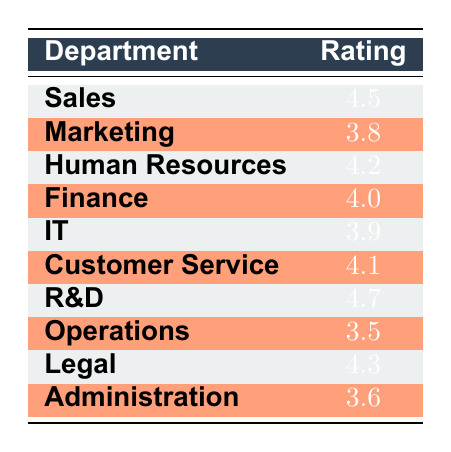What is the rating for the Human Resources department? The table displays the rating for the Human Resources department in its respective row, which is 4.2.
Answer: 4.2 Which department has the highest rating? By looking through the Ratings in the table, R&D has the highest rating at 4.7, making it the department with the best performance rating.
Answer: R&D What is the average rating of the Sales, Marketing, and IT departments? The ratings for those departments are 4.5 (Sales), 3.8 (Marketing), and 3.9 (IT). To find the average, sum them: 4.5 + 3.8 + 3.9 = 12.2, then divide by 3 (12.2 / 3 = 4.067).
Answer: 4.067 Is the rating for Customer Service higher than that of Administration? The Customer Service department has a rating of 4.1 while Administration has a rating of 3.6. Since 4.1 is greater than 3.6, the answer is yes.
Answer: Yes What is the difference in ratings between Operations and Legal departments? Operations has a rating of 3.5 and Legal has a rating of 4.3. To find the difference, subtract the rating of Operations from Legal: 4.3 - 3.5 = 0.8.
Answer: 0.8 Which departments have ratings above 4.0? The departments with ratings greater than 4.0 include Sales (4.5), Human Resources (4.2), Finance (4.0), R&D (4.7), and Legal (4.3). Therefore, there are five departments.
Answer: Five What is the median rating of all departments listed? The ratings are 4.5, 3.8, 4.2, 4.0, 3.9, 4.1, 4.7, 3.5, 4.3, and 3.6. Sorting them gives: [3.5, 3.6, 3.8, 3.9, 4.0, 4.1, 4.2, 4.3, 4.5, 4.7]. With an even number of ratings (10), the median is the average of the 5th and 6th values: (4.0 + 4.1) / 2 = 4.05.
Answer: 4.05 Does every department have a performance rating of 4.0 or higher? No, Operations (3.5) and Administration (3.6) have ratings below 4.0, meaning not all departments meet this threshold.
Answer: No What is the total sum of ratings across all departments? The ratings sum up to (4.5 + 3.8 + 4.2 + 4.0 + 3.9 + 4.1 + 4.7 + 3.5 + 4.3 + 3.6) = 41.6 in total.
Answer: 41.6 